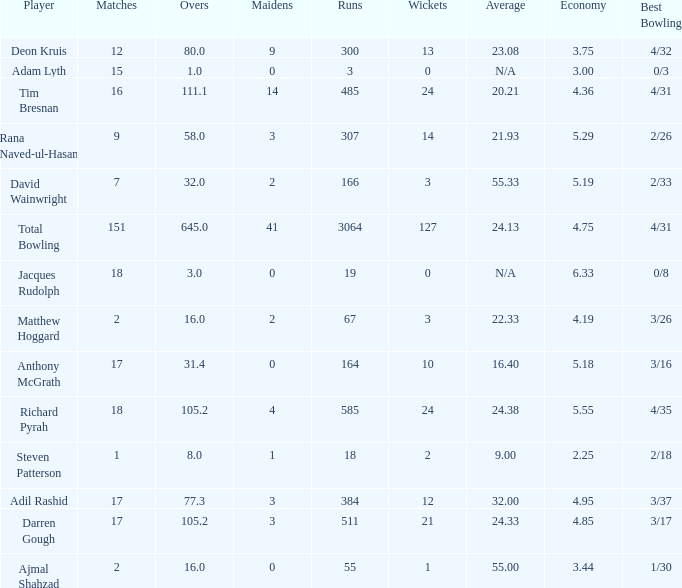What is the lowest Overs with a Run that is 18? 8.0. 